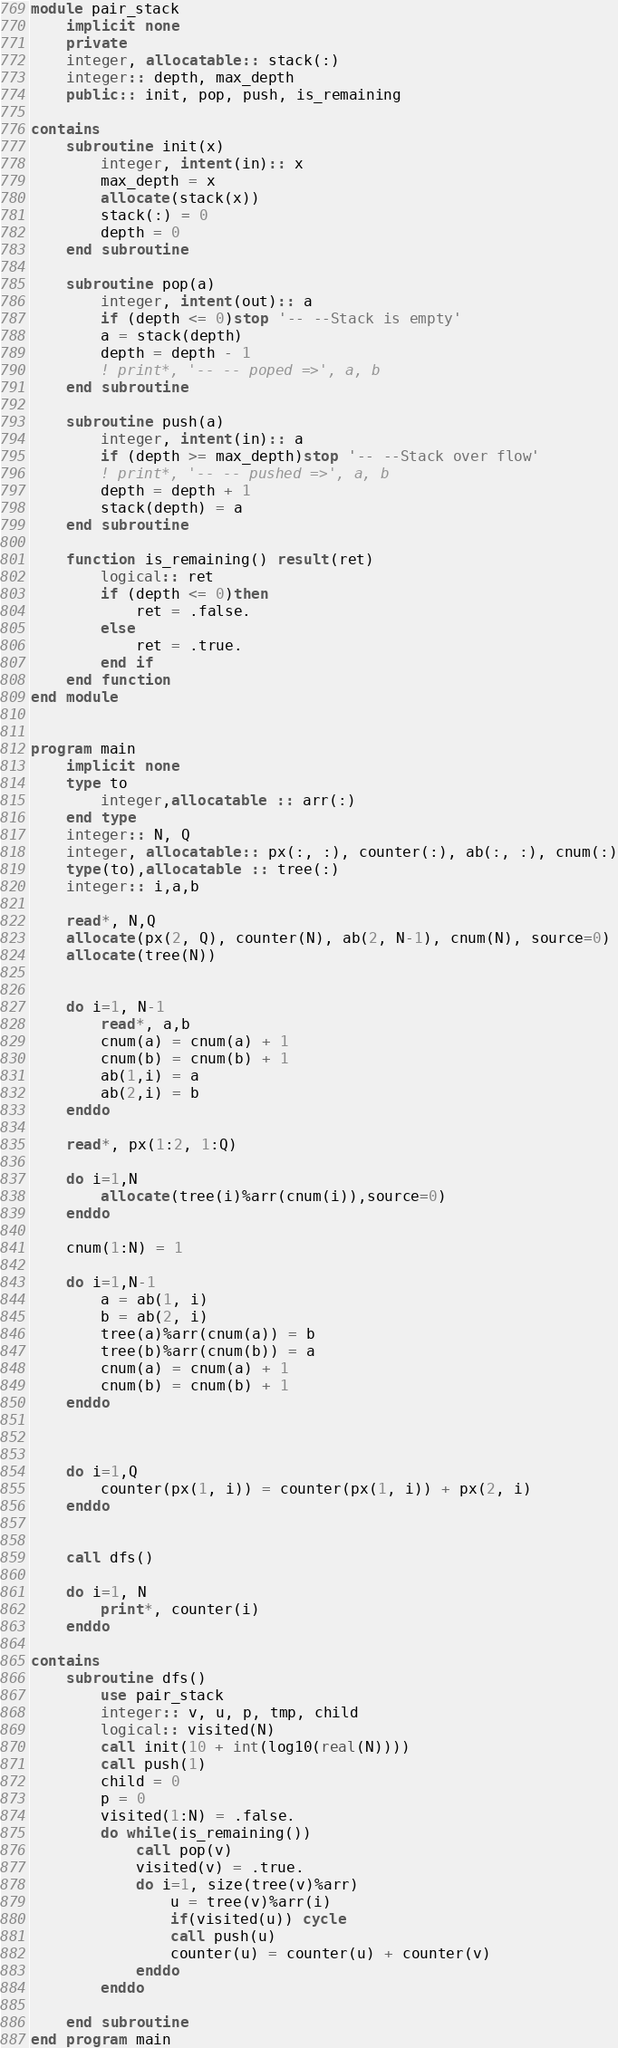Convert code to text. <code><loc_0><loc_0><loc_500><loc_500><_FORTRAN_>module pair_stack
    implicit none
    private
    integer, allocatable:: stack(:)
    integer:: depth, max_depth
    public:: init, pop, push, is_remaining

contains
    subroutine init(x)
        integer, intent(in):: x
        max_depth = x
        allocate(stack(x))
        stack(:) = 0
        depth = 0
    end subroutine

    subroutine pop(a)
        integer, intent(out):: a
        if (depth <= 0)stop '-- --Stack is empty'
        a = stack(depth)
        depth = depth - 1
        ! print*, '-- -- poped =>', a, b
    end subroutine

    subroutine push(a)
        integer, intent(in):: a
        if (depth >= max_depth)stop '-- --Stack over flow'
        ! print*, '-- -- pushed =>', a, b
        depth = depth + 1
        stack(depth) = a
    end subroutine

    function is_remaining() result(ret)
        logical:: ret
        if (depth <= 0)then
            ret = .false.
        else
            ret = .true.
        end if
    end function
end module


program main
    implicit none
    type to
        integer,allocatable :: arr(:)
    end type
    integer:: N, Q
    integer, allocatable:: px(:, :), counter(:), ab(:, :), cnum(:)
    type(to),allocatable :: tree(:)
    integer:: i,a,b

    read*, N,Q
    allocate(px(2, Q), counter(N), ab(2, N-1), cnum(N), source=0)
    allocate(tree(N))


    do i=1, N-1
        read*, a,b
        cnum(a) = cnum(a) + 1
        cnum(b) = cnum(b) + 1
        ab(1,i) = a
        ab(2,i) = b
    enddo

    read*, px(1:2, 1:Q)

    do i=1,N
        allocate(tree(i)%arr(cnum(i)),source=0)
    enddo

    cnum(1:N) = 1

    do i=1,N-1
        a = ab(1, i)
        b = ab(2, i)
        tree(a)%arr(cnum(a)) = b
        tree(b)%arr(cnum(b)) = a
        cnum(a) = cnum(a) + 1
        cnum(b) = cnum(b) + 1
    enddo



    do i=1,Q
        counter(px(1, i)) = counter(px(1, i)) + px(2, i)
    enddo


    call dfs()
    
    do i=1, N
        print*, counter(i)
    enddo

contains
    subroutine dfs()
        use pair_stack
        integer:: v, u, p, tmp, child
        logical:: visited(N)
        call init(10 + int(log10(real(N))))
        call push(1)
        child = 0
        p = 0
        visited(1:N) = .false.
        do while(is_remaining())
            call pop(v)
            visited(v) = .true.
            do i=1, size(tree(v)%arr)
                u = tree(v)%arr(i)
                if(visited(u)) cycle
                call push(u)
                counter(u) = counter(u) + counter(v)
            enddo
        enddo

    end subroutine
end program main</code> 